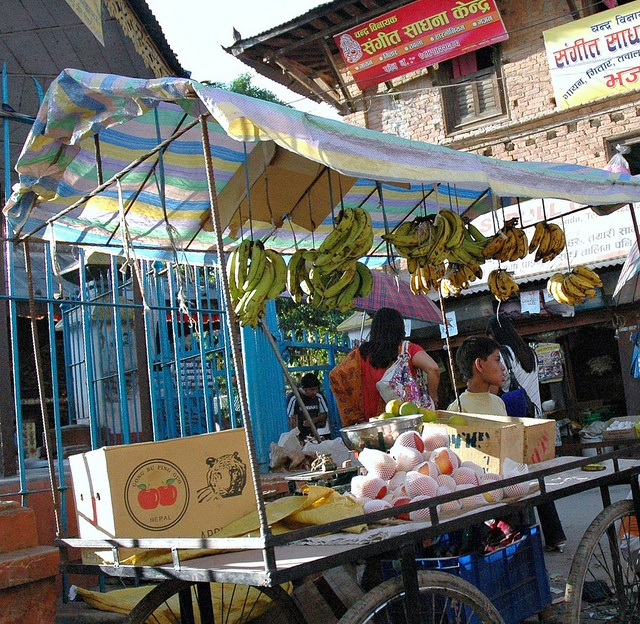Describe the objects in this image and their specific colors. I can see people in gray, maroon, and black tones, people in gray, black, darkgray, and navy tones, banana in gray, darkgreen, and black tones, people in gray, black, maroon, and darkgray tones, and banana in gray, olive, and black tones in this image. 